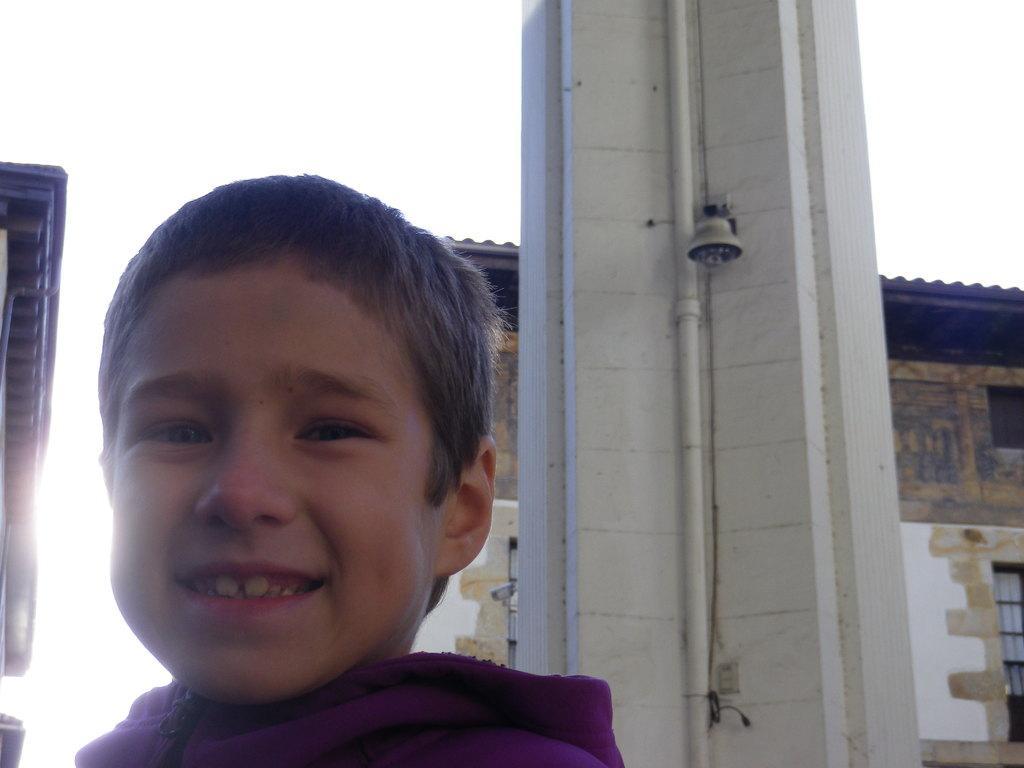In one or two sentences, can you explain what this image depicts? This is boy, this is house and a sky. 